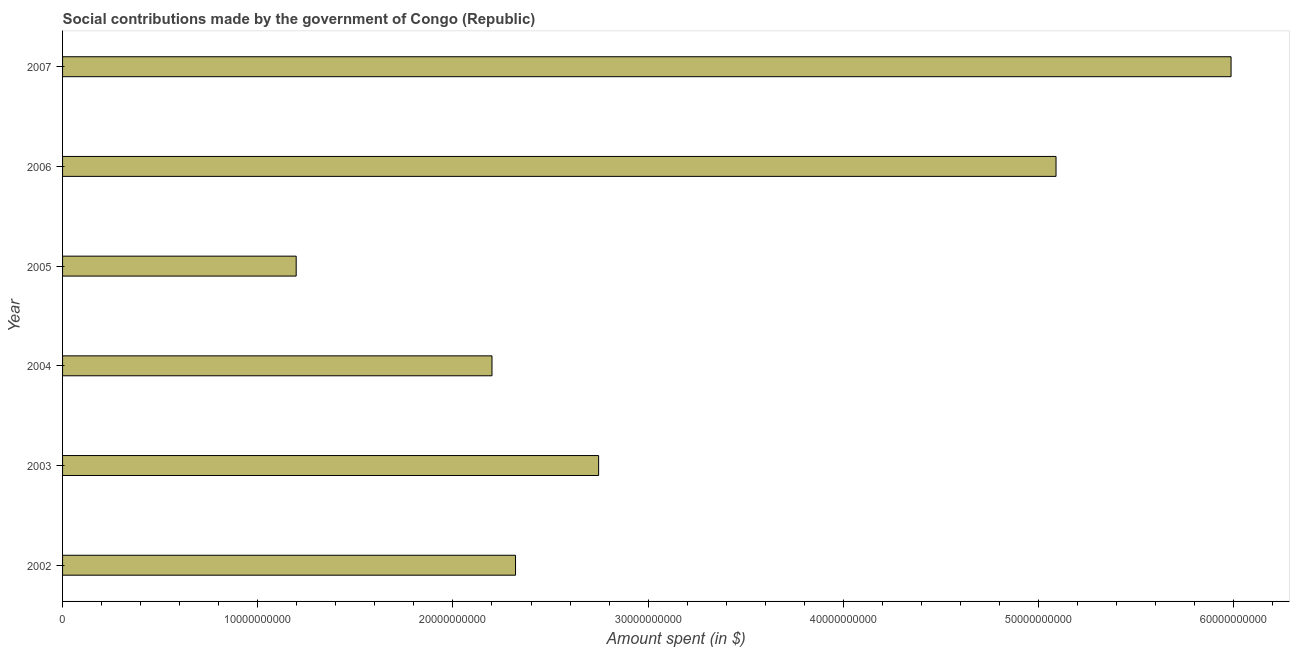What is the title of the graph?
Your response must be concise. Social contributions made by the government of Congo (Republic). What is the label or title of the X-axis?
Your answer should be compact. Amount spent (in $). What is the amount spent in making social contributions in 2005?
Offer a terse response. 1.20e+1. Across all years, what is the maximum amount spent in making social contributions?
Your response must be concise. 5.99e+1. Across all years, what is the minimum amount spent in making social contributions?
Ensure brevity in your answer.  1.20e+1. In which year was the amount spent in making social contributions maximum?
Make the answer very short. 2007. What is the sum of the amount spent in making social contributions?
Offer a very short reply. 1.95e+11. What is the difference between the amount spent in making social contributions in 2006 and 2007?
Your response must be concise. -8.97e+09. What is the average amount spent in making social contributions per year?
Provide a succinct answer. 3.26e+1. What is the median amount spent in making social contributions?
Provide a short and direct response. 2.53e+1. Do a majority of the years between 2007 and 2005 (inclusive) have amount spent in making social contributions greater than 44000000000 $?
Ensure brevity in your answer.  Yes. What is the ratio of the amount spent in making social contributions in 2003 to that in 2006?
Give a very brief answer. 0.54. Is the difference between the amount spent in making social contributions in 2004 and 2006 greater than the difference between any two years?
Give a very brief answer. No. What is the difference between the highest and the second highest amount spent in making social contributions?
Make the answer very short. 8.97e+09. What is the difference between the highest and the lowest amount spent in making social contributions?
Your answer should be very brief. 4.79e+1. In how many years, is the amount spent in making social contributions greater than the average amount spent in making social contributions taken over all years?
Provide a short and direct response. 2. Are all the bars in the graph horizontal?
Your response must be concise. Yes. How many years are there in the graph?
Offer a terse response. 6. What is the difference between two consecutive major ticks on the X-axis?
Give a very brief answer. 1.00e+1. What is the Amount spent (in $) of 2002?
Offer a terse response. 2.32e+1. What is the Amount spent (in $) in 2003?
Provide a succinct answer. 2.75e+1. What is the Amount spent (in $) in 2004?
Make the answer very short. 2.20e+1. What is the Amount spent (in $) in 2005?
Your answer should be very brief. 1.20e+1. What is the Amount spent (in $) of 2006?
Your response must be concise. 5.09e+1. What is the Amount spent (in $) of 2007?
Provide a succinct answer. 5.99e+1. What is the difference between the Amount spent (in $) in 2002 and 2003?
Your answer should be compact. -4.26e+09. What is the difference between the Amount spent (in $) in 2002 and 2004?
Offer a very short reply. 1.21e+09. What is the difference between the Amount spent (in $) in 2002 and 2005?
Provide a short and direct response. 1.12e+1. What is the difference between the Amount spent (in $) in 2002 and 2006?
Ensure brevity in your answer.  -2.77e+1. What is the difference between the Amount spent (in $) in 2002 and 2007?
Your answer should be very brief. -3.67e+1. What is the difference between the Amount spent (in $) in 2003 and 2004?
Make the answer very short. 5.46e+09. What is the difference between the Amount spent (in $) in 2003 and 2005?
Provide a short and direct response. 1.55e+1. What is the difference between the Amount spent (in $) in 2003 and 2006?
Make the answer very short. -2.34e+1. What is the difference between the Amount spent (in $) in 2003 and 2007?
Keep it short and to the point. -3.24e+1. What is the difference between the Amount spent (in $) in 2004 and 2005?
Make the answer very short. 1.00e+1. What is the difference between the Amount spent (in $) in 2004 and 2006?
Provide a short and direct response. -2.89e+1. What is the difference between the Amount spent (in $) in 2004 and 2007?
Your answer should be compact. -3.79e+1. What is the difference between the Amount spent (in $) in 2005 and 2006?
Offer a very short reply. -3.89e+1. What is the difference between the Amount spent (in $) in 2005 and 2007?
Keep it short and to the point. -4.79e+1. What is the difference between the Amount spent (in $) in 2006 and 2007?
Your response must be concise. -8.97e+09. What is the ratio of the Amount spent (in $) in 2002 to that in 2003?
Make the answer very short. 0.84. What is the ratio of the Amount spent (in $) in 2002 to that in 2004?
Give a very brief answer. 1.05. What is the ratio of the Amount spent (in $) in 2002 to that in 2005?
Give a very brief answer. 1.94. What is the ratio of the Amount spent (in $) in 2002 to that in 2006?
Provide a succinct answer. 0.46. What is the ratio of the Amount spent (in $) in 2002 to that in 2007?
Offer a very short reply. 0.39. What is the ratio of the Amount spent (in $) in 2003 to that in 2004?
Ensure brevity in your answer.  1.25. What is the ratio of the Amount spent (in $) in 2003 to that in 2005?
Keep it short and to the point. 2.29. What is the ratio of the Amount spent (in $) in 2003 to that in 2006?
Keep it short and to the point. 0.54. What is the ratio of the Amount spent (in $) in 2003 to that in 2007?
Keep it short and to the point. 0.46. What is the ratio of the Amount spent (in $) in 2004 to that in 2005?
Your response must be concise. 1.84. What is the ratio of the Amount spent (in $) in 2004 to that in 2006?
Make the answer very short. 0.43. What is the ratio of the Amount spent (in $) in 2004 to that in 2007?
Offer a very short reply. 0.37. What is the ratio of the Amount spent (in $) in 2005 to that in 2006?
Give a very brief answer. 0.23. What is the ratio of the Amount spent (in $) in 2005 to that in 2007?
Offer a very short reply. 0.2. 